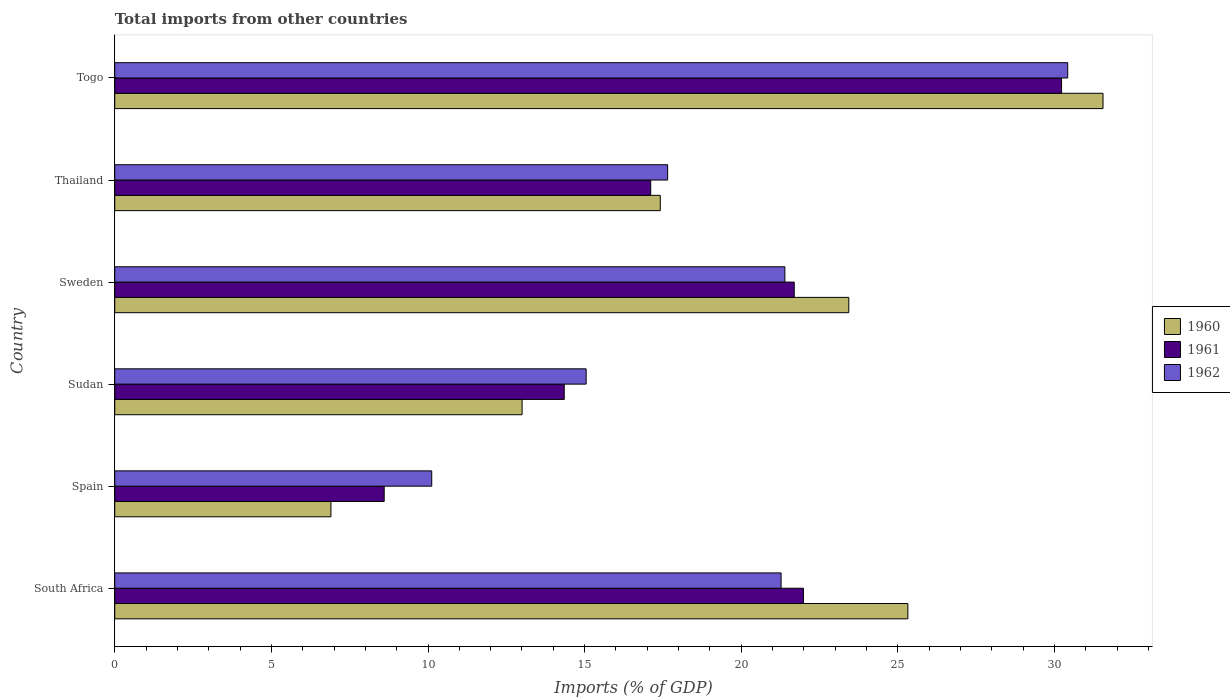How many different coloured bars are there?
Your answer should be compact. 3. How many groups of bars are there?
Your answer should be compact. 6. Are the number of bars per tick equal to the number of legend labels?
Provide a succinct answer. Yes. How many bars are there on the 6th tick from the top?
Provide a succinct answer. 3. What is the label of the 6th group of bars from the top?
Your response must be concise. South Africa. What is the total imports in 1961 in Thailand?
Give a very brief answer. 17.11. Across all countries, what is the maximum total imports in 1962?
Offer a terse response. 30.42. Across all countries, what is the minimum total imports in 1961?
Offer a very short reply. 8.6. In which country was the total imports in 1961 maximum?
Provide a succinct answer. Togo. What is the total total imports in 1960 in the graph?
Your answer should be compact. 117.62. What is the difference between the total imports in 1961 in South Africa and that in Spain?
Keep it short and to the point. 13.38. What is the difference between the total imports in 1960 in Thailand and the total imports in 1961 in Sweden?
Give a very brief answer. -4.28. What is the average total imports in 1961 per country?
Give a very brief answer. 18.99. What is the difference between the total imports in 1962 and total imports in 1960 in Spain?
Your response must be concise. 3.22. In how many countries, is the total imports in 1962 greater than 12 %?
Offer a very short reply. 5. What is the ratio of the total imports in 1960 in Sweden to that in Thailand?
Offer a terse response. 1.35. Is the total imports in 1960 in Spain less than that in Thailand?
Make the answer very short. Yes. Is the difference between the total imports in 1962 in South Africa and Thailand greater than the difference between the total imports in 1960 in South Africa and Thailand?
Your answer should be very brief. No. What is the difference between the highest and the second highest total imports in 1961?
Ensure brevity in your answer.  8.24. What is the difference between the highest and the lowest total imports in 1962?
Provide a short and direct response. 20.3. In how many countries, is the total imports in 1960 greater than the average total imports in 1960 taken over all countries?
Make the answer very short. 3. Is the sum of the total imports in 1960 in South Africa and Thailand greater than the maximum total imports in 1962 across all countries?
Your answer should be very brief. Yes. What does the 1st bar from the bottom in Togo represents?
Offer a terse response. 1960. Are all the bars in the graph horizontal?
Provide a succinct answer. Yes. How many countries are there in the graph?
Provide a short and direct response. 6. What is the difference between two consecutive major ticks on the X-axis?
Provide a succinct answer. 5. Are the values on the major ticks of X-axis written in scientific E-notation?
Offer a very short reply. No. Does the graph contain grids?
Keep it short and to the point. No. Where does the legend appear in the graph?
Your answer should be very brief. Center right. What is the title of the graph?
Keep it short and to the point. Total imports from other countries. Does "1982" appear as one of the legend labels in the graph?
Offer a very short reply. No. What is the label or title of the X-axis?
Make the answer very short. Imports (% of GDP). What is the label or title of the Y-axis?
Your answer should be very brief. Country. What is the Imports (% of GDP) in 1960 in South Africa?
Keep it short and to the point. 25.32. What is the Imports (% of GDP) of 1961 in South Africa?
Your answer should be very brief. 21.99. What is the Imports (% of GDP) of 1962 in South Africa?
Provide a short and direct response. 21.27. What is the Imports (% of GDP) in 1960 in Spain?
Your answer should be compact. 6.9. What is the Imports (% of GDP) in 1961 in Spain?
Offer a very short reply. 8.6. What is the Imports (% of GDP) of 1962 in Spain?
Your answer should be compact. 10.12. What is the Imports (% of GDP) in 1960 in Sudan?
Offer a very short reply. 13. What is the Imports (% of GDP) of 1961 in Sudan?
Offer a very short reply. 14.35. What is the Imports (% of GDP) in 1962 in Sudan?
Your answer should be very brief. 15.05. What is the Imports (% of GDP) of 1960 in Sweden?
Offer a terse response. 23.43. What is the Imports (% of GDP) of 1961 in Sweden?
Keep it short and to the point. 21.69. What is the Imports (% of GDP) of 1962 in Sweden?
Offer a very short reply. 21.39. What is the Imports (% of GDP) of 1960 in Thailand?
Your answer should be very brief. 17.42. What is the Imports (% of GDP) of 1961 in Thailand?
Provide a short and direct response. 17.11. What is the Imports (% of GDP) in 1962 in Thailand?
Provide a succinct answer. 17.65. What is the Imports (% of GDP) of 1960 in Togo?
Offer a very short reply. 31.55. What is the Imports (% of GDP) of 1961 in Togo?
Provide a succinct answer. 30.23. What is the Imports (% of GDP) in 1962 in Togo?
Your answer should be compact. 30.42. Across all countries, what is the maximum Imports (% of GDP) in 1960?
Your response must be concise. 31.55. Across all countries, what is the maximum Imports (% of GDP) in 1961?
Make the answer very short. 30.23. Across all countries, what is the maximum Imports (% of GDP) of 1962?
Give a very brief answer. 30.42. Across all countries, what is the minimum Imports (% of GDP) in 1960?
Your answer should be very brief. 6.9. Across all countries, what is the minimum Imports (% of GDP) of 1961?
Provide a short and direct response. 8.6. Across all countries, what is the minimum Imports (% of GDP) in 1962?
Provide a succinct answer. 10.12. What is the total Imports (% of GDP) in 1960 in the graph?
Make the answer very short. 117.62. What is the total Imports (% of GDP) of 1961 in the graph?
Make the answer very short. 113.96. What is the total Imports (% of GDP) in 1962 in the graph?
Ensure brevity in your answer.  115.9. What is the difference between the Imports (% of GDP) in 1960 in South Africa and that in Spain?
Make the answer very short. 18.42. What is the difference between the Imports (% of GDP) in 1961 in South Africa and that in Spain?
Make the answer very short. 13.38. What is the difference between the Imports (% of GDP) in 1962 in South Africa and that in Spain?
Give a very brief answer. 11.15. What is the difference between the Imports (% of GDP) of 1960 in South Africa and that in Sudan?
Keep it short and to the point. 12.32. What is the difference between the Imports (% of GDP) of 1961 in South Africa and that in Sudan?
Give a very brief answer. 7.64. What is the difference between the Imports (% of GDP) in 1962 in South Africa and that in Sudan?
Provide a succinct answer. 6.22. What is the difference between the Imports (% of GDP) in 1960 in South Africa and that in Sweden?
Your answer should be compact. 1.89. What is the difference between the Imports (% of GDP) of 1961 in South Africa and that in Sweden?
Ensure brevity in your answer.  0.29. What is the difference between the Imports (% of GDP) in 1962 in South Africa and that in Sweden?
Your response must be concise. -0.12. What is the difference between the Imports (% of GDP) of 1960 in South Africa and that in Thailand?
Offer a very short reply. 7.9. What is the difference between the Imports (% of GDP) of 1961 in South Africa and that in Thailand?
Make the answer very short. 4.88. What is the difference between the Imports (% of GDP) of 1962 in South Africa and that in Thailand?
Keep it short and to the point. 3.62. What is the difference between the Imports (% of GDP) of 1960 in South Africa and that in Togo?
Your answer should be very brief. -6.23. What is the difference between the Imports (% of GDP) of 1961 in South Africa and that in Togo?
Make the answer very short. -8.24. What is the difference between the Imports (% of GDP) in 1962 in South Africa and that in Togo?
Keep it short and to the point. -9.15. What is the difference between the Imports (% of GDP) of 1960 in Spain and that in Sudan?
Give a very brief answer. -6.1. What is the difference between the Imports (% of GDP) in 1961 in Spain and that in Sudan?
Offer a terse response. -5.75. What is the difference between the Imports (% of GDP) in 1962 in Spain and that in Sudan?
Ensure brevity in your answer.  -4.93. What is the difference between the Imports (% of GDP) in 1960 in Spain and that in Sweden?
Give a very brief answer. -16.53. What is the difference between the Imports (% of GDP) of 1961 in Spain and that in Sweden?
Provide a short and direct response. -13.09. What is the difference between the Imports (% of GDP) of 1962 in Spain and that in Sweden?
Offer a terse response. -11.27. What is the difference between the Imports (% of GDP) of 1960 in Spain and that in Thailand?
Make the answer very short. -10.51. What is the difference between the Imports (% of GDP) in 1961 in Spain and that in Thailand?
Provide a short and direct response. -8.51. What is the difference between the Imports (% of GDP) in 1962 in Spain and that in Thailand?
Your answer should be compact. -7.53. What is the difference between the Imports (% of GDP) of 1960 in Spain and that in Togo?
Your answer should be compact. -24.65. What is the difference between the Imports (% of GDP) in 1961 in Spain and that in Togo?
Your response must be concise. -21.62. What is the difference between the Imports (% of GDP) of 1962 in Spain and that in Togo?
Provide a short and direct response. -20.3. What is the difference between the Imports (% of GDP) in 1960 in Sudan and that in Sweden?
Provide a succinct answer. -10.43. What is the difference between the Imports (% of GDP) of 1961 in Sudan and that in Sweden?
Provide a succinct answer. -7.34. What is the difference between the Imports (% of GDP) in 1962 in Sudan and that in Sweden?
Offer a terse response. -6.34. What is the difference between the Imports (% of GDP) of 1960 in Sudan and that in Thailand?
Provide a succinct answer. -4.41. What is the difference between the Imports (% of GDP) of 1961 in Sudan and that in Thailand?
Offer a very short reply. -2.76. What is the difference between the Imports (% of GDP) of 1962 in Sudan and that in Thailand?
Your response must be concise. -2.6. What is the difference between the Imports (% of GDP) in 1960 in Sudan and that in Togo?
Keep it short and to the point. -18.55. What is the difference between the Imports (% of GDP) of 1961 in Sudan and that in Togo?
Your response must be concise. -15.88. What is the difference between the Imports (% of GDP) in 1962 in Sudan and that in Togo?
Your answer should be compact. -15.37. What is the difference between the Imports (% of GDP) in 1960 in Sweden and that in Thailand?
Give a very brief answer. 6.02. What is the difference between the Imports (% of GDP) of 1961 in Sweden and that in Thailand?
Make the answer very short. 4.58. What is the difference between the Imports (% of GDP) in 1962 in Sweden and that in Thailand?
Keep it short and to the point. 3.74. What is the difference between the Imports (% of GDP) of 1960 in Sweden and that in Togo?
Keep it short and to the point. -8.12. What is the difference between the Imports (% of GDP) in 1961 in Sweden and that in Togo?
Give a very brief answer. -8.53. What is the difference between the Imports (% of GDP) in 1962 in Sweden and that in Togo?
Provide a short and direct response. -9.03. What is the difference between the Imports (% of GDP) in 1960 in Thailand and that in Togo?
Offer a terse response. -14.13. What is the difference between the Imports (% of GDP) in 1961 in Thailand and that in Togo?
Your response must be concise. -13.12. What is the difference between the Imports (% of GDP) in 1962 in Thailand and that in Togo?
Keep it short and to the point. -12.77. What is the difference between the Imports (% of GDP) of 1960 in South Africa and the Imports (% of GDP) of 1961 in Spain?
Give a very brief answer. 16.72. What is the difference between the Imports (% of GDP) of 1960 in South Africa and the Imports (% of GDP) of 1962 in Spain?
Provide a short and direct response. 15.2. What is the difference between the Imports (% of GDP) of 1961 in South Africa and the Imports (% of GDP) of 1962 in Spain?
Provide a succinct answer. 11.87. What is the difference between the Imports (% of GDP) in 1960 in South Africa and the Imports (% of GDP) in 1961 in Sudan?
Provide a short and direct response. 10.97. What is the difference between the Imports (% of GDP) in 1960 in South Africa and the Imports (% of GDP) in 1962 in Sudan?
Your answer should be compact. 10.27. What is the difference between the Imports (% of GDP) in 1961 in South Africa and the Imports (% of GDP) in 1962 in Sudan?
Provide a succinct answer. 6.94. What is the difference between the Imports (% of GDP) of 1960 in South Africa and the Imports (% of GDP) of 1961 in Sweden?
Provide a short and direct response. 3.63. What is the difference between the Imports (% of GDP) of 1960 in South Africa and the Imports (% of GDP) of 1962 in Sweden?
Your answer should be compact. 3.93. What is the difference between the Imports (% of GDP) in 1961 in South Africa and the Imports (% of GDP) in 1962 in Sweden?
Provide a succinct answer. 0.59. What is the difference between the Imports (% of GDP) of 1960 in South Africa and the Imports (% of GDP) of 1961 in Thailand?
Keep it short and to the point. 8.21. What is the difference between the Imports (% of GDP) in 1960 in South Africa and the Imports (% of GDP) in 1962 in Thailand?
Make the answer very short. 7.67. What is the difference between the Imports (% of GDP) of 1961 in South Africa and the Imports (% of GDP) of 1962 in Thailand?
Keep it short and to the point. 4.34. What is the difference between the Imports (% of GDP) of 1960 in South Africa and the Imports (% of GDP) of 1961 in Togo?
Your answer should be very brief. -4.91. What is the difference between the Imports (% of GDP) of 1960 in South Africa and the Imports (% of GDP) of 1962 in Togo?
Offer a terse response. -5.1. What is the difference between the Imports (% of GDP) in 1961 in South Africa and the Imports (% of GDP) in 1962 in Togo?
Ensure brevity in your answer.  -8.44. What is the difference between the Imports (% of GDP) of 1960 in Spain and the Imports (% of GDP) of 1961 in Sudan?
Provide a succinct answer. -7.45. What is the difference between the Imports (% of GDP) of 1960 in Spain and the Imports (% of GDP) of 1962 in Sudan?
Your response must be concise. -8.15. What is the difference between the Imports (% of GDP) of 1961 in Spain and the Imports (% of GDP) of 1962 in Sudan?
Ensure brevity in your answer.  -6.45. What is the difference between the Imports (% of GDP) of 1960 in Spain and the Imports (% of GDP) of 1961 in Sweden?
Your response must be concise. -14.79. What is the difference between the Imports (% of GDP) in 1960 in Spain and the Imports (% of GDP) in 1962 in Sweden?
Your answer should be compact. -14.49. What is the difference between the Imports (% of GDP) of 1961 in Spain and the Imports (% of GDP) of 1962 in Sweden?
Make the answer very short. -12.79. What is the difference between the Imports (% of GDP) of 1960 in Spain and the Imports (% of GDP) of 1961 in Thailand?
Your answer should be very brief. -10.21. What is the difference between the Imports (% of GDP) of 1960 in Spain and the Imports (% of GDP) of 1962 in Thailand?
Provide a succinct answer. -10.75. What is the difference between the Imports (% of GDP) in 1961 in Spain and the Imports (% of GDP) in 1962 in Thailand?
Your response must be concise. -9.05. What is the difference between the Imports (% of GDP) in 1960 in Spain and the Imports (% of GDP) in 1961 in Togo?
Offer a terse response. -23.32. What is the difference between the Imports (% of GDP) in 1960 in Spain and the Imports (% of GDP) in 1962 in Togo?
Offer a terse response. -23.52. What is the difference between the Imports (% of GDP) in 1961 in Spain and the Imports (% of GDP) in 1962 in Togo?
Make the answer very short. -21.82. What is the difference between the Imports (% of GDP) of 1960 in Sudan and the Imports (% of GDP) of 1961 in Sweden?
Ensure brevity in your answer.  -8.69. What is the difference between the Imports (% of GDP) of 1960 in Sudan and the Imports (% of GDP) of 1962 in Sweden?
Ensure brevity in your answer.  -8.39. What is the difference between the Imports (% of GDP) in 1961 in Sudan and the Imports (% of GDP) in 1962 in Sweden?
Your answer should be very brief. -7.04. What is the difference between the Imports (% of GDP) of 1960 in Sudan and the Imports (% of GDP) of 1961 in Thailand?
Provide a succinct answer. -4.11. What is the difference between the Imports (% of GDP) in 1960 in Sudan and the Imports (% of GDP) in 1962 in Thailand?
Your answer should be very brief. -4.65. What is the difference between the Imports (% of GDP) in 1960 in Sudan and the Imports (% of GDP) in 1961 in Togo?
Your answer should be very brief. -17.22. What is the difference between the Imports (% of GDP) of 1960 in Sudan and the Imports (% of GDP) of 1962 in Togo?
Your answer should be very brief. -17.42. What is the difference between the Imports (% of GDP) in 1961 in Sudan and the Imports (% of GDP) in 1962 in Togo?
Offer a very short reply. -16.07. What is the difference between the Imports (% of GDP) of 1960 in Sweden and the Imports (% of GDP) of 1961 in Thailand?
Keep it short and to the point. 6.32. What is the difference between the Imports (% of GDP) of 1960 in Sweden and the Imports (% of GDP) of 1962 in Thailand?
Give a very brief answer. 5.78. What is the difference between the Imports (% of GDP) in 1961 in Sweden and the Imports (% of GDP) in 1962 in Thailand?
Offer a very short reply. 4.04. What is the difference between the Imports (% of GDP) of 1960 in Sweden and the Imports (% of GDP) of 1961 in Togo?
Provide a succinct answer. -6.79. What is the difference between the Imports (% of GDP) of 1960 in Sweden and the Imports (% of GDP) of 1962 in Togo?
Make the answer very short. -6.99. What is the difference between the Imports (% of GDP) in 1961 in Sweden and the Imports (% of GDP) in 1962 in Togo?
Offer a very short reply. -8.73. What is the difference between the Imports (% of GDP) in 1960 in Thailand and the Imports (% of GDP) in 1961 in Togo?
Provide a succinct answer. -12.81. What is the difference between the Imports (% of GDP) in 1960 in Thailand and the Imports (% of GDP) in 1962 in Togo?
Your answer should be compact. -13.01. What is the difference between the Imports (% of GDP) in 1961 in Thailand and the Imports (% of GDP) in 1962 in Togo?
Provide a short and direct response. -13.31. What is the average Imports (% of GDP) of 1960 per country?
Offer a terse response. 19.6. What is the average Imports (% of GDP) of 1961 per country?
Ensure brevity in your answer.  18.99. What is the average Imports (% of GDP) in 1962 per country?
Offer a very short reply. 19.32. What is the difference between the Imports (% of GDP) of 1960 and Imports (% of GDP) of 1961 in South Africa?
Give a very brief answer. 3.33. What is the difference between the Imports (% of GDP) of 1960 and Imports (% of GDP) of 1962 in South Africa?
Your response must be concise. 4.05. What is the difference between the Imports (% of GDP) of 1961 and Imports (% of GDP) of 1962 in South Africa?
Offer a terse response. 0.71. What is the difference between the Imports (% of GDP) of 1960 and Imports (% of GDP) of 1961 in Spain?
Give a very brief answer. -1.7. What is the difference between the Imports (% of GDP) in 1960 and Imports (% of GDP) in 1962 in Spain?
Your answer should be compact. -3.22. What is the difference between the Imports (% of GDP) in 1961 and Imports (% of GDP) in 1962 in Spain?
Make the answer very short. -1.52. What is the difference between the Imports (% of GDP) in 1960 and Imports (% of GDP) in 1961 in Sudan?
Make the answer very short. -1.35. What is the difference between the Imports (% of GDP) of 1960 and Imports (% of GDP) of 1962 in Sudan?
Provide a succinct answer. -2.05. What is the difference between the Imports (% of GDP) in 1961 and Imports (% of GDP) in 1962 in Sudan?
Give a very brief answer. -0.7. What is the difference between the Imports (% of GDP) of 1960 and Imports (% of GDP) of 1961 in Sweden?
Your answer should be compact. 1.74. What is the difference between the Imports (% of GDP) in 1960 and Imports (% of GDP) in 1962 in Sweden?
Ensure brevity in your answer.  2.04. What is the difference between the Imports (% of GDP) in 1961 and Imports (% of GDP) in 1962 in Sweden?
Your answer should be very brief. 0.3. What is the difference between the Imports (% of GDP) of 1960 and Imports (% of GDP) of 1961 in Thailand?
Make the answer very short. 0.31. What is the difference between the Imports (% of GDP) in 1960 and Imports (% of GDP) in 1962 in Thailand?
Make the answer very short. -0.23. What is the difference between the Imports (% of GDP) in 1961 and Imports (% of GDP) in 1962 in Thailand?
Your answer should be very brief. -0.54. What is the difference between the Imports (% of GDP) of 1960 and Imports (% of GDP) of 1961 in Togo?
Your answer should be very brief. 1.32. What is the difference between the Imports (% of GDP) in 1960 and Imports (% of GDP) in 1962 in Togo?
Your response must be concise. 1.13. What is the difference between the Imports (% of GDP) in 1961 and Imports (% of GDP) in 1962 in Togo?
Offer a terse response. -0.2. What is the ratio of the Imports (% of GDP) of 1960 in South Africa to that in Spain?
Your answer should be compact. 3.67. What is the ratio of the Imports (% of GDP) in 1961 in South Africa to that in Spain?
Ensure brevity in your answer.  2.56. What is the ratio of the Imports (% of GDP) in 1962 in South Africa to that in Spain?
Your response must be concise. 2.1. What is the ratio of the Imports (% of GDP) of 1960 in South Africa to that in Sudan?
Offer a terse response. 1.95. What is the ratio of the Imports (% of GDP) in 1961 in South Africa to that in Sudan?
Your response must be concise. 1.53. What is the ratio of the Imports (% of GDP) in 1962 in South Africa to that in Sudan?
Your answer should be very brief. 1.41. What is the ratio of the Imports (% of GDP) in 1960 in South Africa to that in Sweden?
Provide a short and direct response. 1.08. What is the ratio of the Imports (% of GDP) in 1961 in South Africa to that in Sweden?
Keep it short and to the point. 1.01. What is the ratio of the Imports (% of GDP) of 1962 in South Africa to that in Sweden?
Give a very brief answer. 0.99. What is the ratio of the Imports (% of GDP) in 1960 in South Africa to that in Thailand?
Provide a succinct answer. 1.45. What is the ratio of the Imports (% of GDP) of 1961 in South Africa to that in Thailand?
Keep it short and to the point. 1.28. What is the ratio of the Imports (% of GDP) in 1962 in South Africa to that in Thailand?
Offer a very short reply. 1.21. What is the ratio of the Imports (% of GDP) in 1960 in South Africa to that in Togo?
Provide a succinct answer. 0.8. What is the ratio of the Imports (% of GDP) in 1961 in South Africa to that in Togo?
Your answer should be very brief. 0.73. What is the ratio of the Imports (% of GDP) of 1962 in South Africa to that in Togo?
Your answer should be compact. 0.7. What is the ratio of the Imports (% of GDP) in 1960 in Spain to that in Sudan?
Keep it short and to the point. 0.53. What is the ratio of the Imports (% of GDP) in 1961 in Spain to that in Sudan?
Your answer should be very brief. 0.6. What is the ratio of the Imports (% of GDP) of 1962 in Spain to that in Sudan?
Offer a very short reply. 0.67. What is the ratio of the Imports (% of GDP) in 1960 in Spain to that in Sweden?
Your answer should be very brief. 0.29. What is the ratio of the Imports (% of GDP) of 1961 in Spain to that in Sweden?
Offer a terse response. 0.4. What is the ratio of the Imports (% of GDP) of 1962 in Spain to that in Sweden?
Offer a very short reply. 0.47. What is the ratio of the Imports (% of GDP) in 1960 in Spain to that in Thailand?
Make the answer very short. 0.4. What is the ratio of the Imports (% of GDP) of 1961 in Spain to that in Thailand?
Keep it short and to the point. 0.5. What is the ratio of the Imports (% of GDP) of 1962 in Spain to that in Thailand?
Your response must be concise. 0.57. What is the ratio of the Imports (% of GDP) in 1960 in Spain to that in Togo?
Provide a succinct answer. 0.22. What is the ratio of the Imports (% of GDP) of 1961 in Spain to that in Togo?
Keep it short and to the point. 0.28. What is the ratio of the Imports (% of GDP) in 1962 in Spain to that in Togo?
Offer a very short reply. 0.33. What is the ratio of the Imports (% of GDP) of 1960 in Sudan to that in Sweden?
Your answer should be very brief. 0.55. What is the ratio of the Imports (% of GDP) of 1961 in Sudan to that in Sweden?
Provide a short and direct response. 0.66. What is the ratio of the Imports (% of GDP) in 1962 in Sudan to that in Sweden?
Make the answer very short. 0.7. What is the ratio of the Imports (% of GDP) in 1960 in Sudan to that in Thailand?
Keep it short and to the point. 0.75. What is the ratio of the Imports (% of GDP) of 1961 in Sudan to that in Thailand?
Offer a terse response. 0.84. What is the ratio of the Imports (% of GDP) of 1962 in Sudan to that in Thailand?
Your answer should be very brief. 0.85. What is the ratio of the Imports (% of GDP) of 1960 in Sudan to that in Togo?
Your answer should be compact. 0.41. What is the ratio of the Imports (% of GDP) of 1961 in Sudan to that in Togo?
Provide a short and direct response. 0.47. What is the ratio of the Imports (% of GDP) in 1962 in Sudan to that in Togo?
Provide a succinct answer. 0.49. What is the ratio of the Imports (% of GDP) of 1960 in Sweden to that in Thailand?
Offer a terse response. 1.35. What is the ratio of the Imports (% of GDP) in 1961 in Sweden to that in Thailand?
Provide a succinct answer. 1.27. What is the ratio of the Imports (% of GDP) of 1962 in Sweden to that in Thailand?
Provide a succinct answer. 1.21. What is the ratio of the Imports (% of GDP) in 1960 in Sweden to that in Togo?
Give a very brief answer. 0.74. What is the ratio of the Imports (% of GDP) in 1961 in Sweden to that in Togo?
Offer a terse response. 0.72. What is the ratio of the Imports (% of GDP) of 1962 in Sweden to that in Togo?
Give a very brief answer. 0.7. What is the ratio of the Imports (% of GDP) in 1960 in Thailand to that in Togo?
Give a very brief answer. 0.55. What is the ratio of the Imports (% of GDP) in 1961 in Thailand to that in Togo?
Ensure brevity in your answer.  0.57. What is the ratio of the Imports (% of GDP) in 1962 in Thailand to that in Togo?
Keep it short and to the point. 0.58. What is the difference between the highest and the second highest Imports (% of GDP) in 1960?
Your answer should be compact. 6.23. What is the difference between the highest and the second highest Imports (% of GDP) in 1961?
Your answer should be compact. 8.24. What is the difference between the highest and the second highest Imports (% of GDP) of 1962?
Give a very brief answer. 9.03. What is the difference between the highest and the lowest Imports (% of GDP) in 1960?
Provide a succinct answer. 24.65. What is the difference between the highest and the lowest Imports (% of GDP) of 1961?
Your answer should be compact. 21.62. What is the difference between the highest and the lowest Imports (% of GDP) in 1962?
Offer a very short reply. 20.3. 